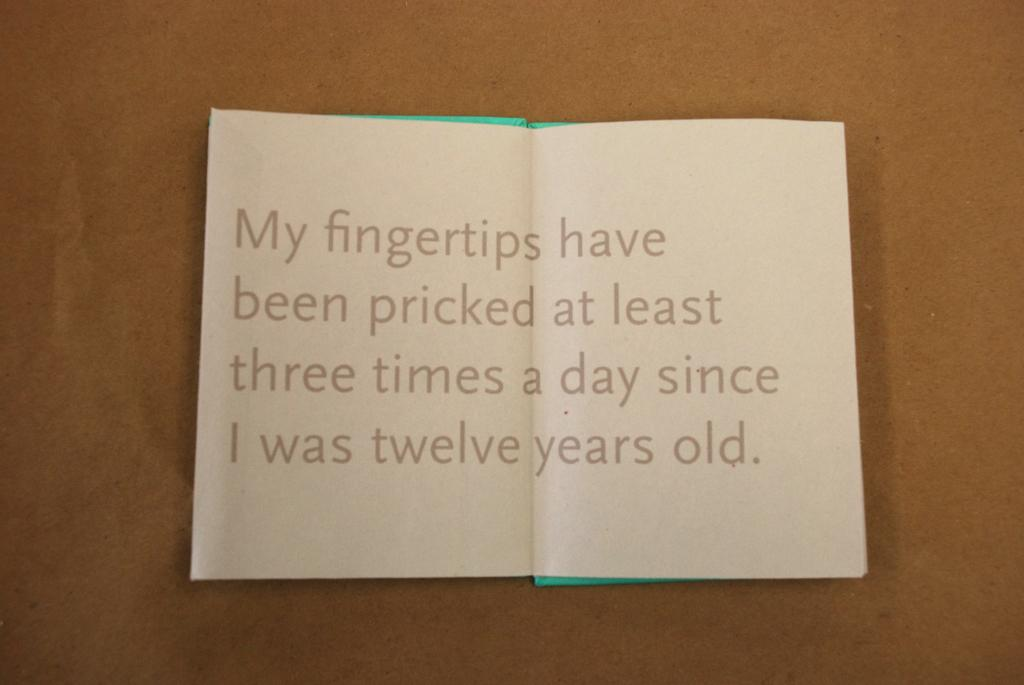<image>
Render a clear and concise summary of the photo. A note that says my fingertips have been pricked at least three times a day since I was twelve years old 